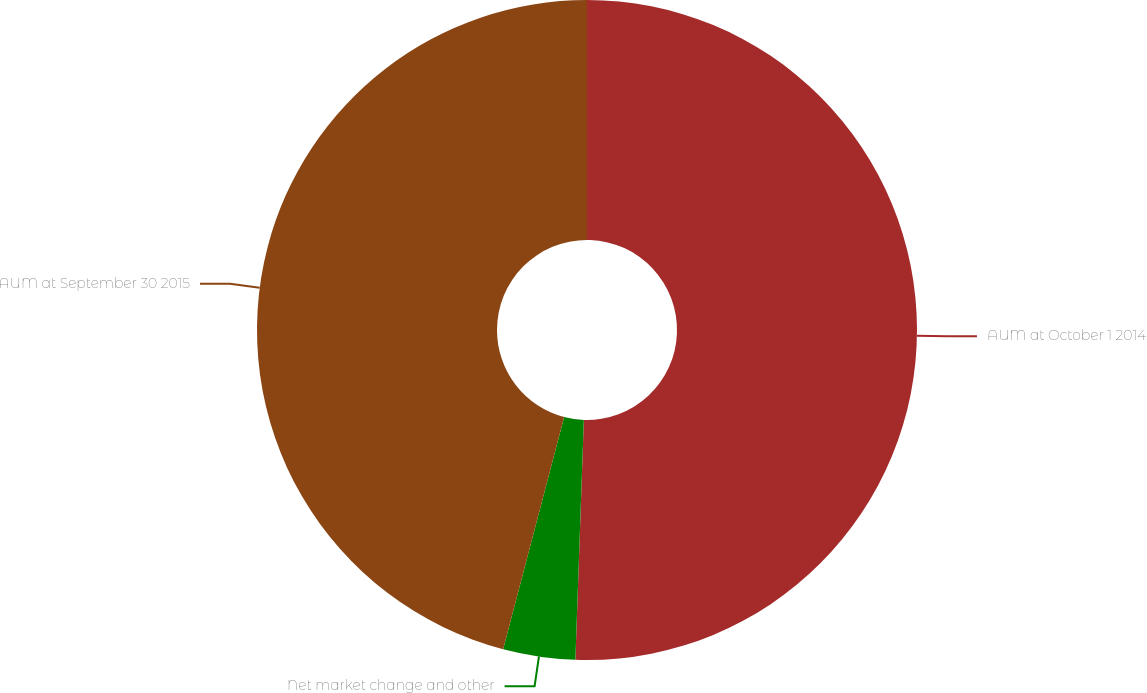<chart> <loc_0><loc_0><loc_500><loc_500><pie_chart><fcel>AUM at October 1 2014<fcel>Net market change and other<fcel>AUM at September 30 2015<nl><fcel>50.56%<fcel>3.53%<fcel>45.91%<nl></chart> 